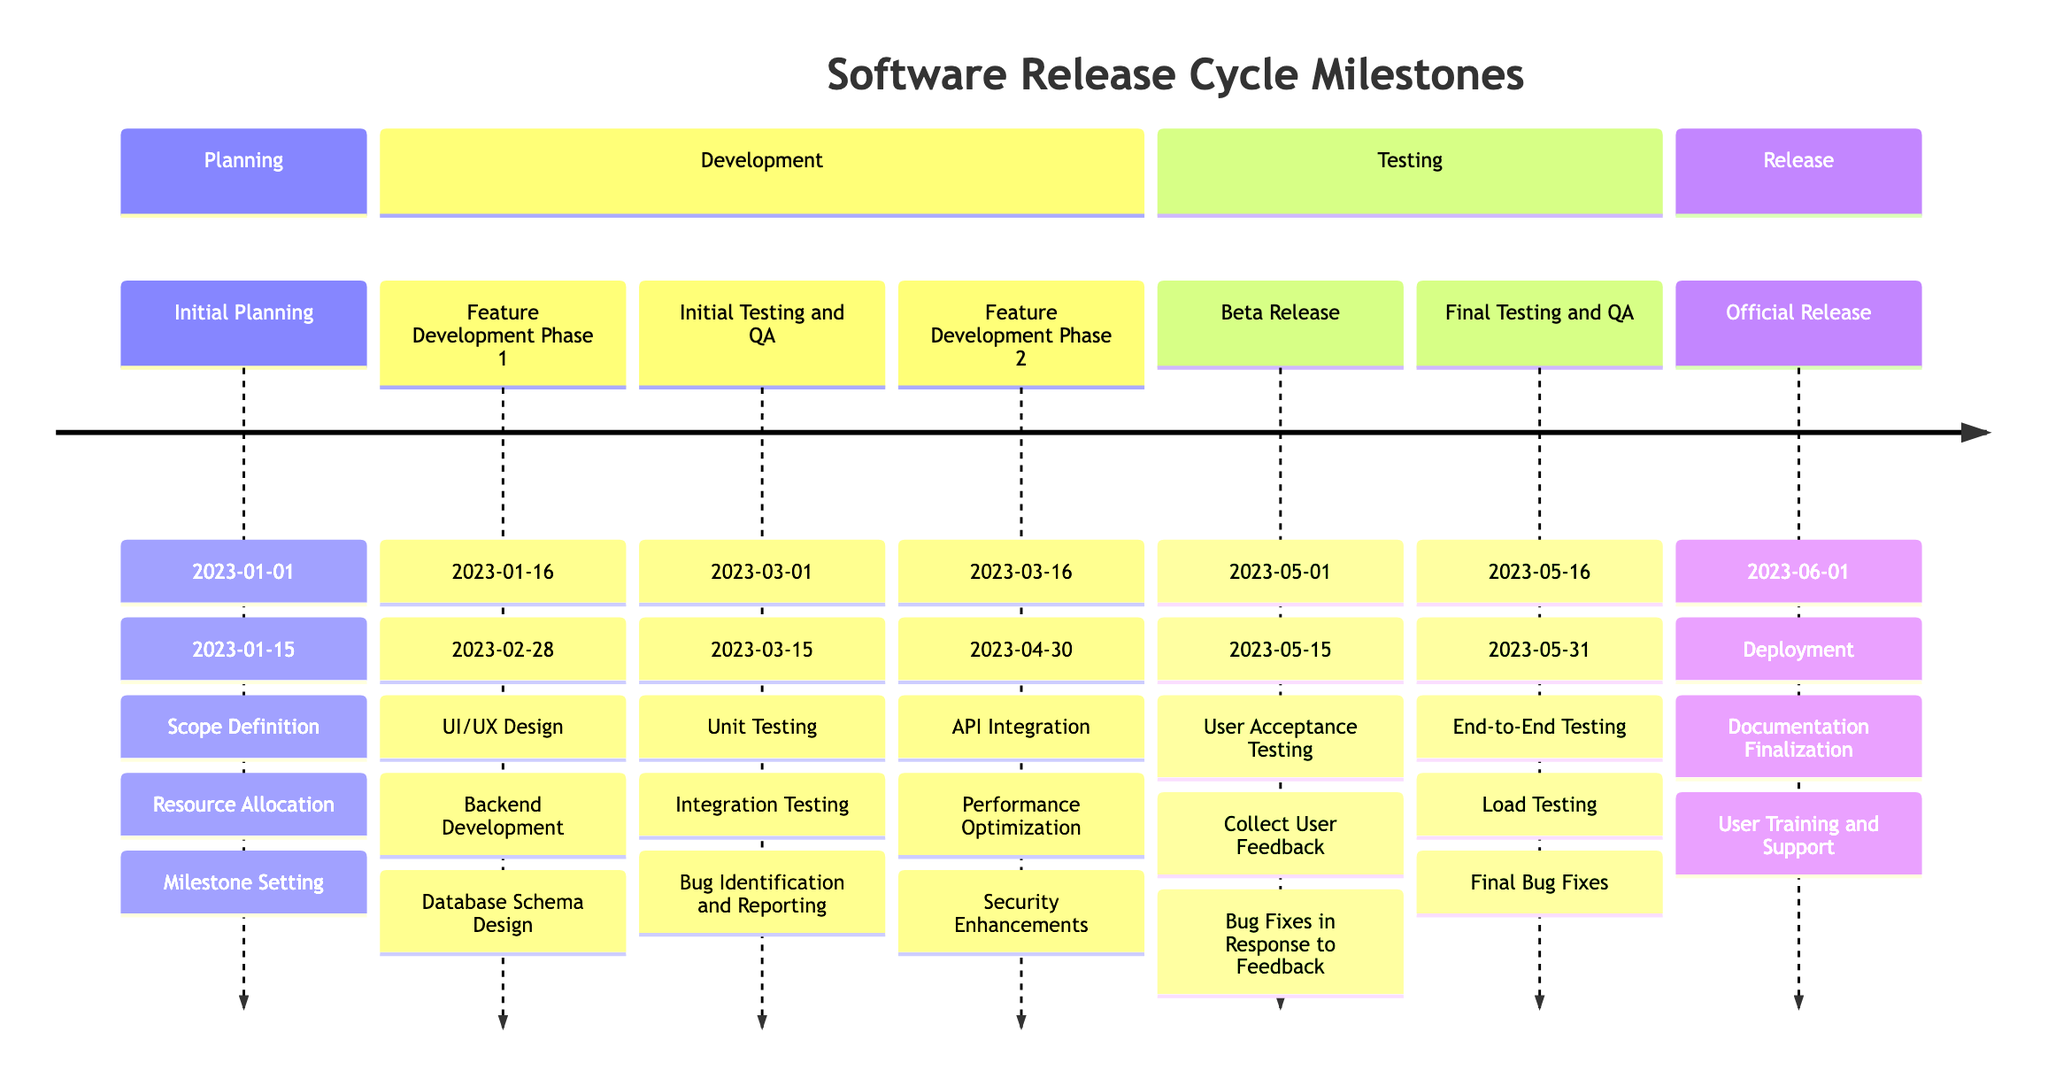What is the duration of the Initial Planning phase? The Initial Planning phase starts on January 1, 2023, and ends on January 15, 2023. To find the duration, we can simply count the days between these two dates, which totals 15 days.
Answer: 15 days How many key features are included in the Beta Release milestone? The Beta Release milestone lists three key features: User Acceptance Testing, Collect User Feedback, and Bug Fixes in Response to Feedback. Therefore, there are three key features in this milestone.
Answer: 3 Which milestone follows the Feature Development Phase 1? The timeline shows that the Feature Development Phase 1 ends on February 28, 2023, and is followed by the Initial Testing and QA milestone, which starts on March 1, 2023. Hence, the milestone that follows is Initial Testing and QA.
Answer: Initial Testing and QA What are the key features of the Official Release? The Official Release milestone has three key features: Deployment, Documentation Finalization, and User Training and Support. This information can be found directly under this milestone in the timeline.
Answer: Deployment, Documentation Finalization, User Training and Support Which phase includes Security Enhancements? Security Enhancements is a key feature listed under Feature Development Phase 2. To find this, we look at the timelines sequentially, and we can see that it is part of the development phases occurring after Initial Testing and QA.
Answer: Feature Development Phase 2 